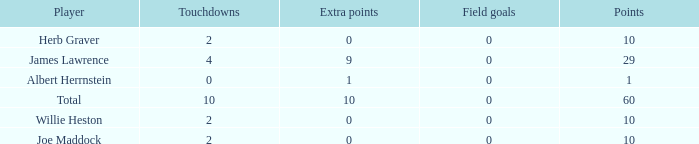What is the highest number of points for players with less than 2 touchdowns and 0 extra points? None. 